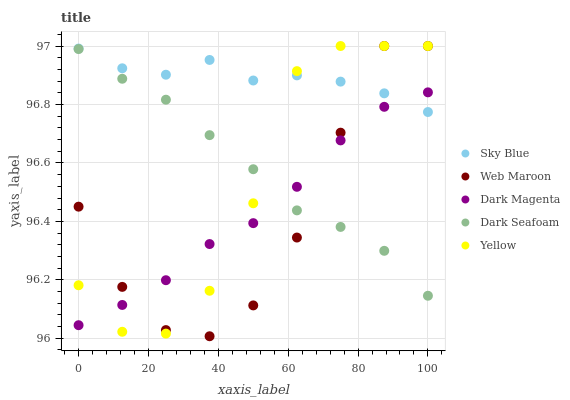Does Web Maroon have the minimum area under the curve?
Answer yes or no. Yes. Does Sky Blue have the maximum area under the curve?
Answer yes or no. Yes. Does Dark Seafoam have the minimum area under the curve?
Answer yes or no. No. Does Dark Seafoam have the maximum area under the curve?
Answer yes or no. No. Is Dark Seafoam the smoothest?
Answer yes or no. Yes. Is Yellow the roughest?
Answer yes or no. Yes. Is Web Maroon the smoothest?
Answer yes or no. No. Is Web Maroon the roughest?
Answer yes or no. No. Does Web Maroon have the lowest value?
Answer yes or no. Yes. Does Dark Seafoam have the lowest value?
Answer yes or no. No. Does Yellow have the highest value?
Answer yes or no. Yes. Does Dark Seafoam have the highest value?
Answer yes or no. No. Is Dark Seafoam less than Sky Blue?
Answer yes or no. Yes. Is Sky Blue greater than Dark Seafoam?
Answer yes or no. Yes. Does Yellow intersect Web Maroon?
Answer yes or no. Yes. Is Yellow less than Web Maroon?
Answer yes or no. No. Is Yellow greater than Web Maroon?
Answer yes or no. No. Does Dark Seafoam intersect Sky Blue?
Answer yes or no. No. 